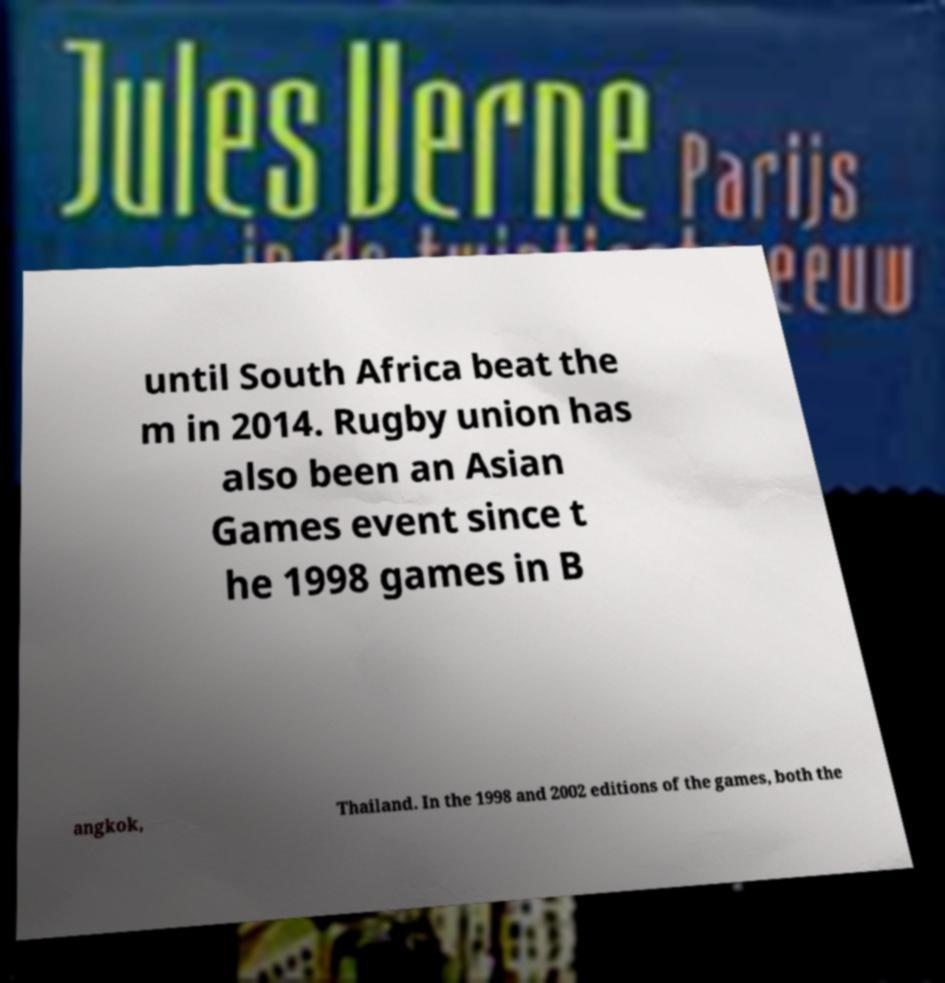Could you extract and type out the text from this image? until South Africa beat the m in 2014. Rugby union has also been an Asian Games event since t he 1998 games in B angkok, Thailand. In the 1998 and 2002 editions of the games, both the 